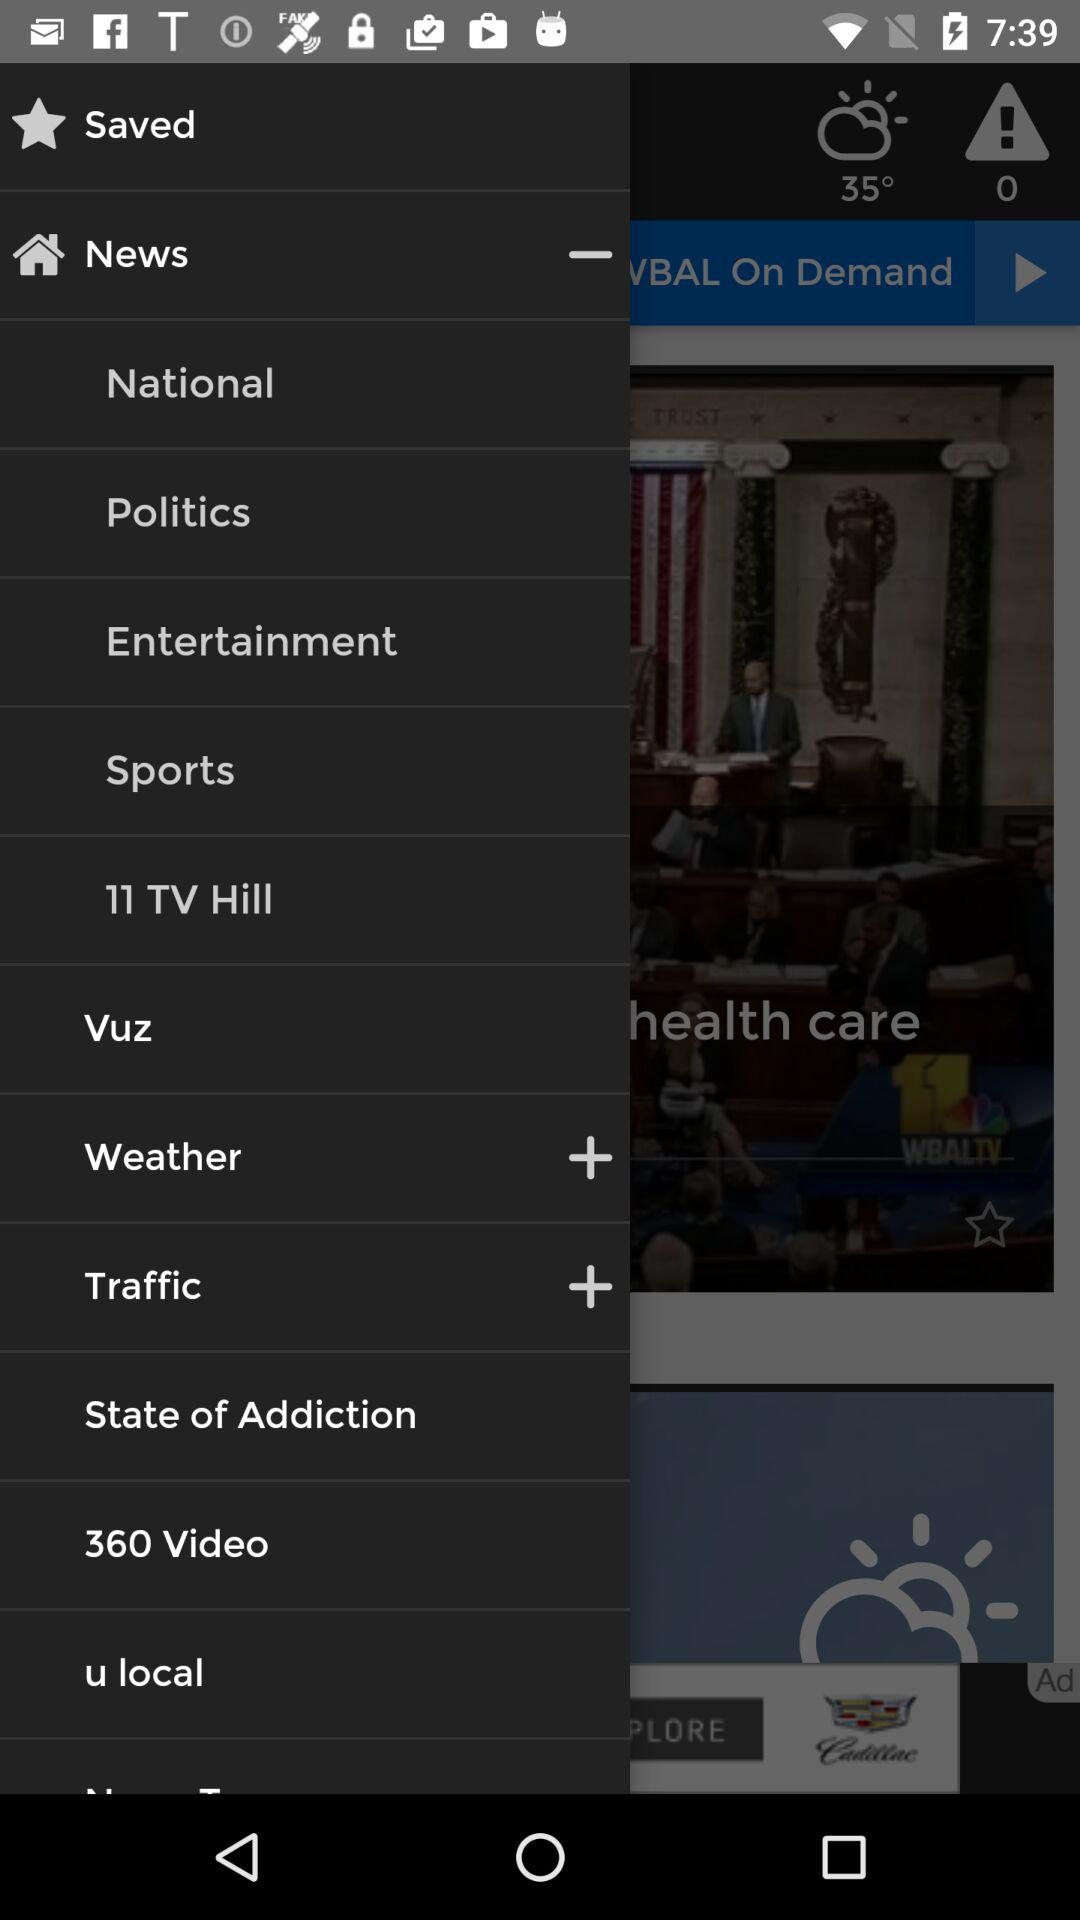How many notifications are there in "Politics"?
When the provided information is insufficient, respond with <no answer>. <no answer> 